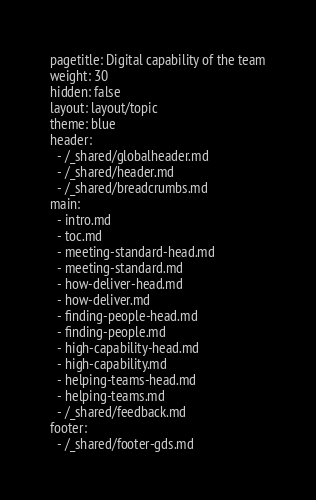<code> <loc_0><loc_0><loc_500><loc_500><_YAML_>pagetitle: Digital capability of the team
weight: 30
hidden: false
layout: layout/topic
theme: blue
header:
  - /_shared/globalheader.md
  - /_shared/header.md
  - /_shared/breadcrumbs.md
main:
  - intro.md
  - toc.md
  - meeting-standard-head.md
  - meeting-standard.md
  - how-deliver-head.md
  - how-deliver.md
  - finding-people-head.md
  - finding-people.md
  - high-capability-head.md
  - high-capability.md
  - helping-teams-head.md
  - helping-teams.md
  - /_shared/feedback.md
footer:
  - /_shared/footer-gds.md
</code> 